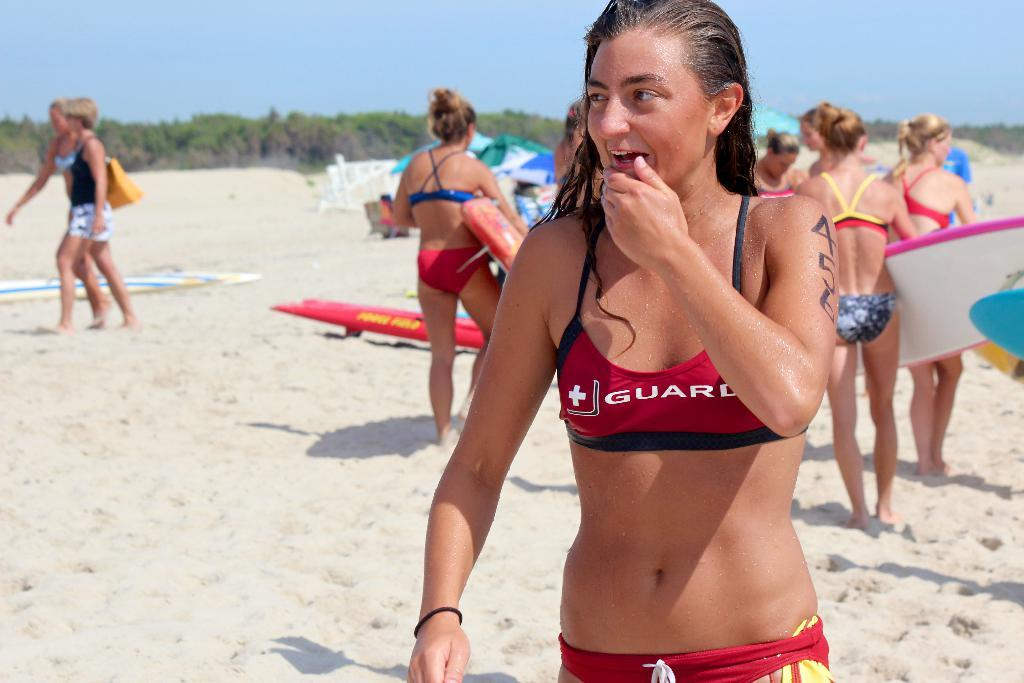What type of individuals are present in the image? There are women standing in the image. Can you describe the general composition of the image? There are people standing in the image. What type of surface are the people standing on? The people are standing on sand. What type of reaction can be seen on the chickens' faces in the image? There are no chickens present in the image, so it is not possible to determine their reactions. 